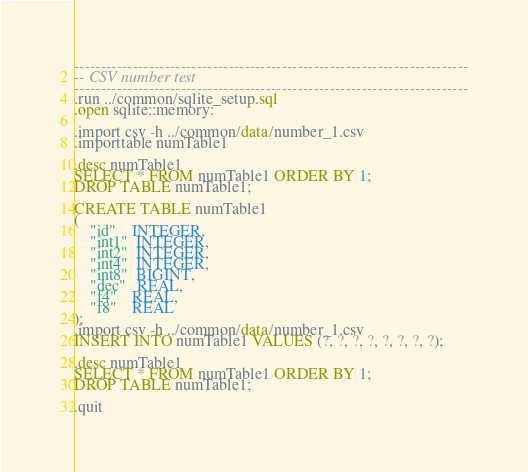<code> <loc_0><loc_0><loc_500><loc_500><_SQL_>--------------------------------------------------------------------------
-- CSV number test
--------------------------------------------------------------------------
.run ../common/sqlite_setup.sql
.open sqlite::memory:

.import csv -h ../common/data/number_1.csv
.importtable numTable1

.desc numTable1
SELECT * FROM numTable1 ORDER BY 1;
DROP TABLE numTable1;

CREATE TABLE numTable1
(
    "id"    INTEGER,
    "int1"  INTEGER,
    "int2"  INTEGER,
    "int4"  INTEGER,
    "int8"  BIGINT,
    "dec"   REAL,
    "f4"    REAL,
    "f8"    REAL
);
.import csv -h ../common/data/number_1.csv
INSERT INTO numTable1 VALUES (?, ?, ?, ?, ?, ?, ?, ?);

.desc numTable1
SELECT * FROM numTable1 ORDER BY 1;
DROP TABLE numTable1;

.quit

</code> 